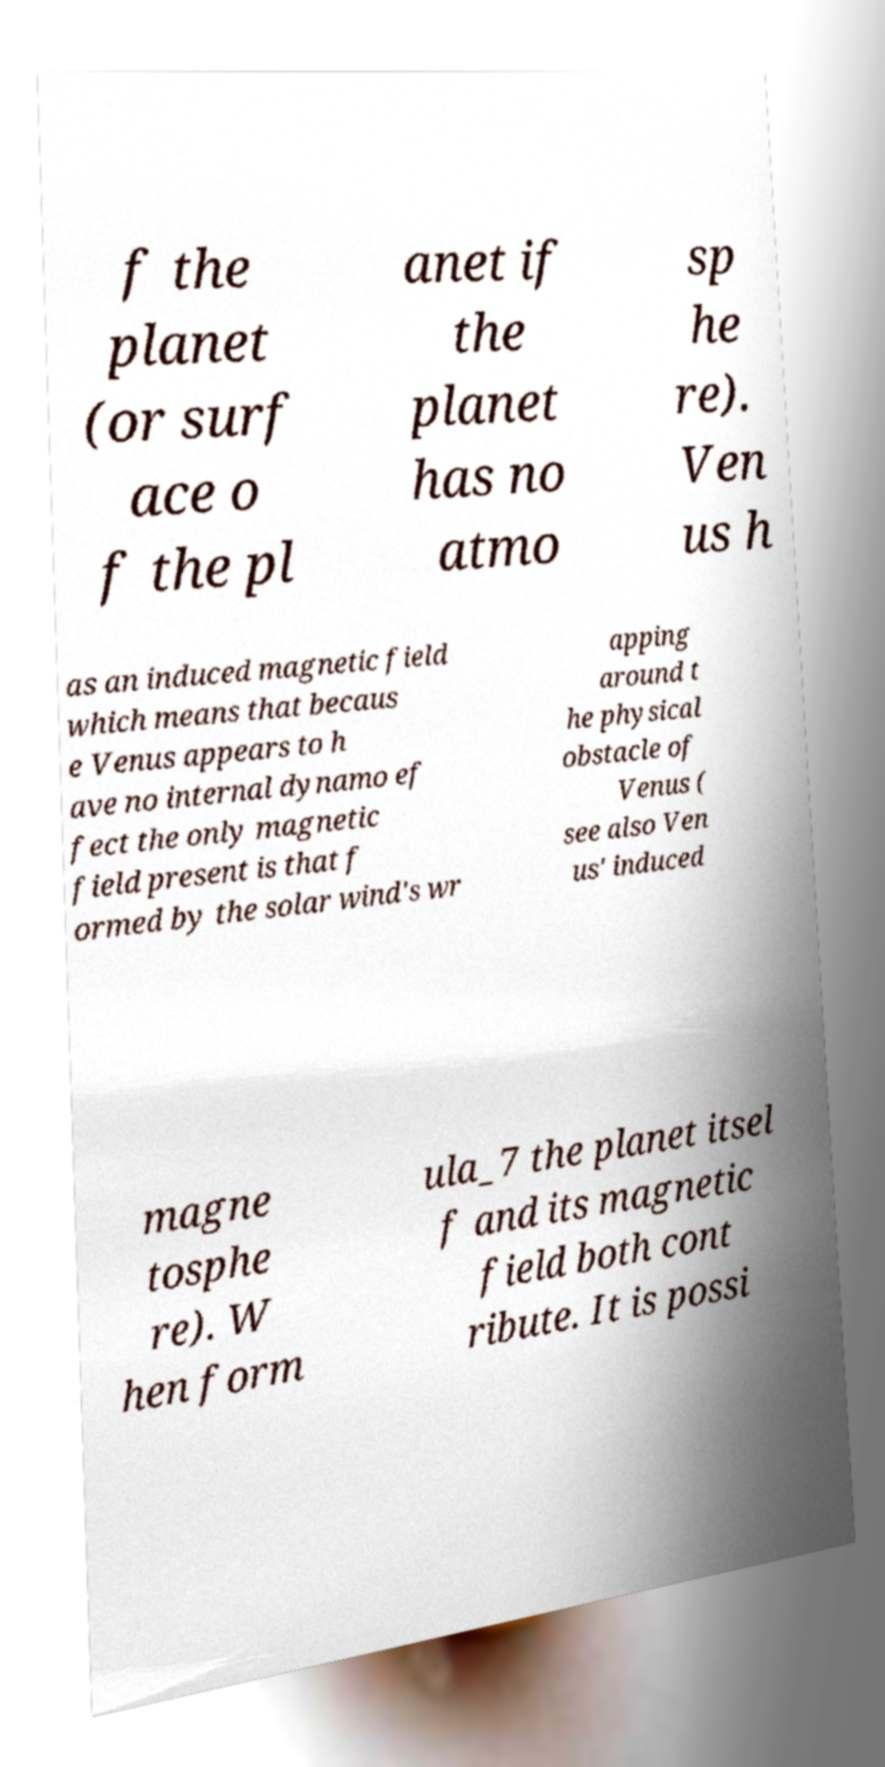There's text embedded in this image that I need extracted. Can you transcribe it verbatim? f the planet (or surf ace o f the pl anet if the planet has no atmo sp he re). Ven us h as an induced magnetic field which means that becaus e Venus appears to h ave no internal dynamo ef fect the only magnetic field present is that f ormed by the solar wind's wr apping around t he physical obstacle of Venus ( see also Ven us' induced magne tosphe re). W hen form ula_7 the planet itsel f and its magnetic field both cont ribute. It is possi 